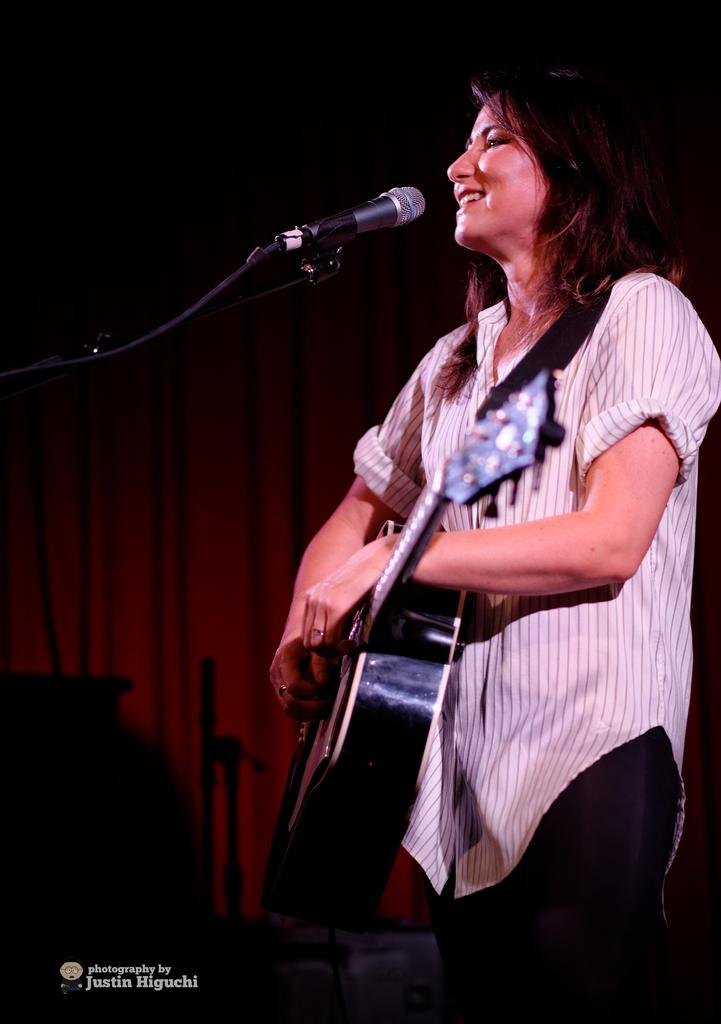What is the main subject of the image? There is a person in the image. What is the person wearing? The person is wearing a white color shirt. What activity is the person engaged in? The person is playing a guitar. What object is in front of the person? There is a microphone in front of the person. How many stamps are on the person's shirt in the image? There are no stamps visible on the person's shirt in the image. What type of teeth does the person have while playing the guitar? The image does not show the person's teeth, so it cannot be determined what type of teeth they have while playing the guitar. 